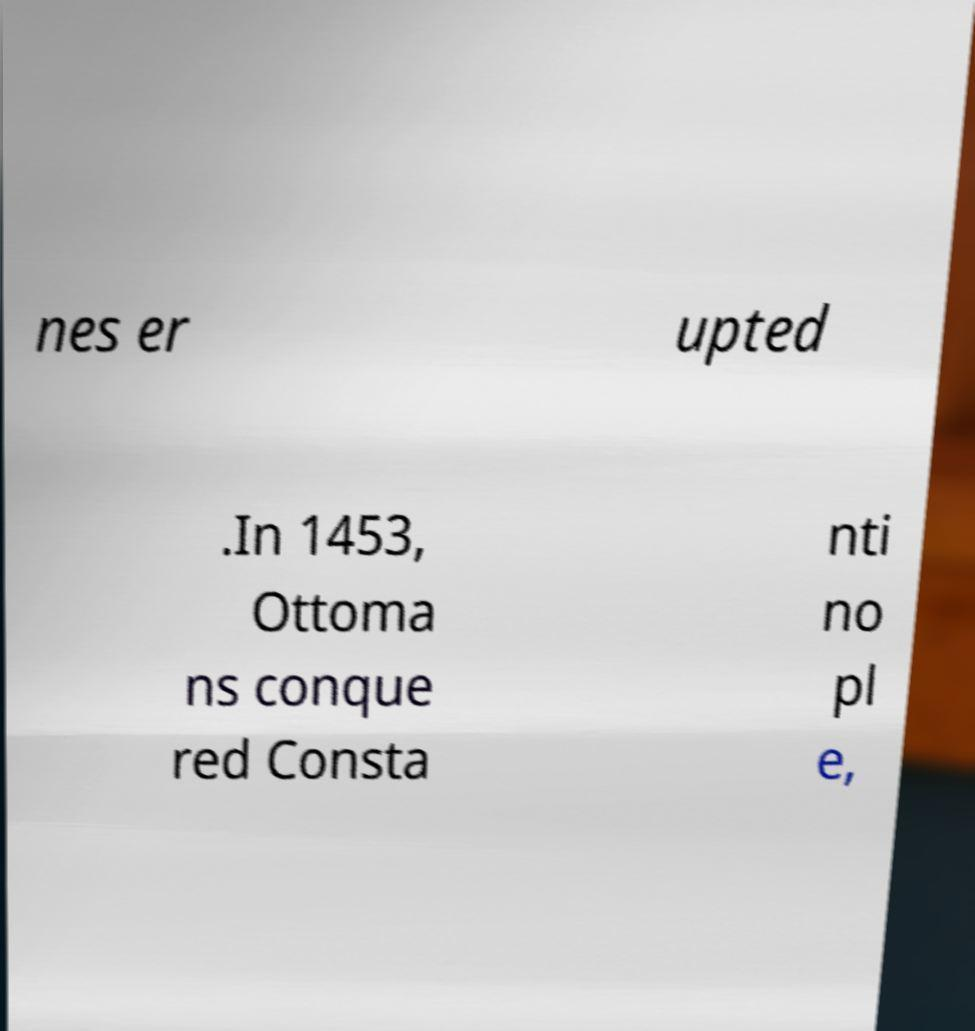Can you accurately transcribe the text from the provided image for me? nes er upted .In 1453, Ottoma ns conque red Consta nti no pl e, 